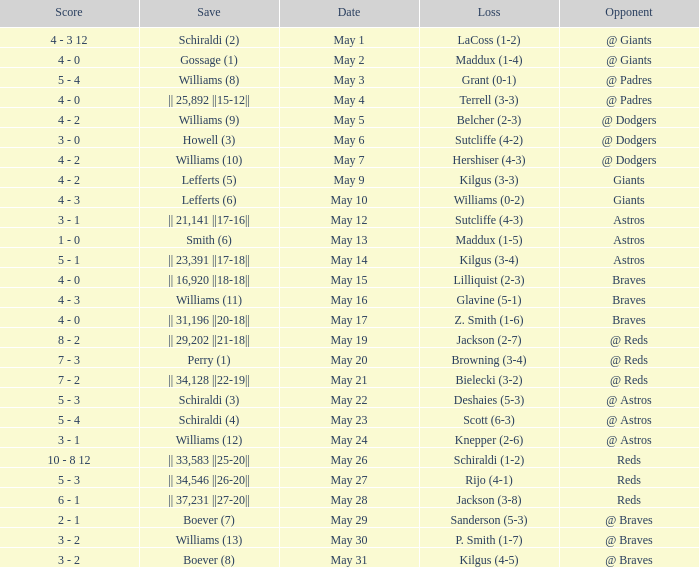Name the opponent for save of williams (9) @ Dodgers. 